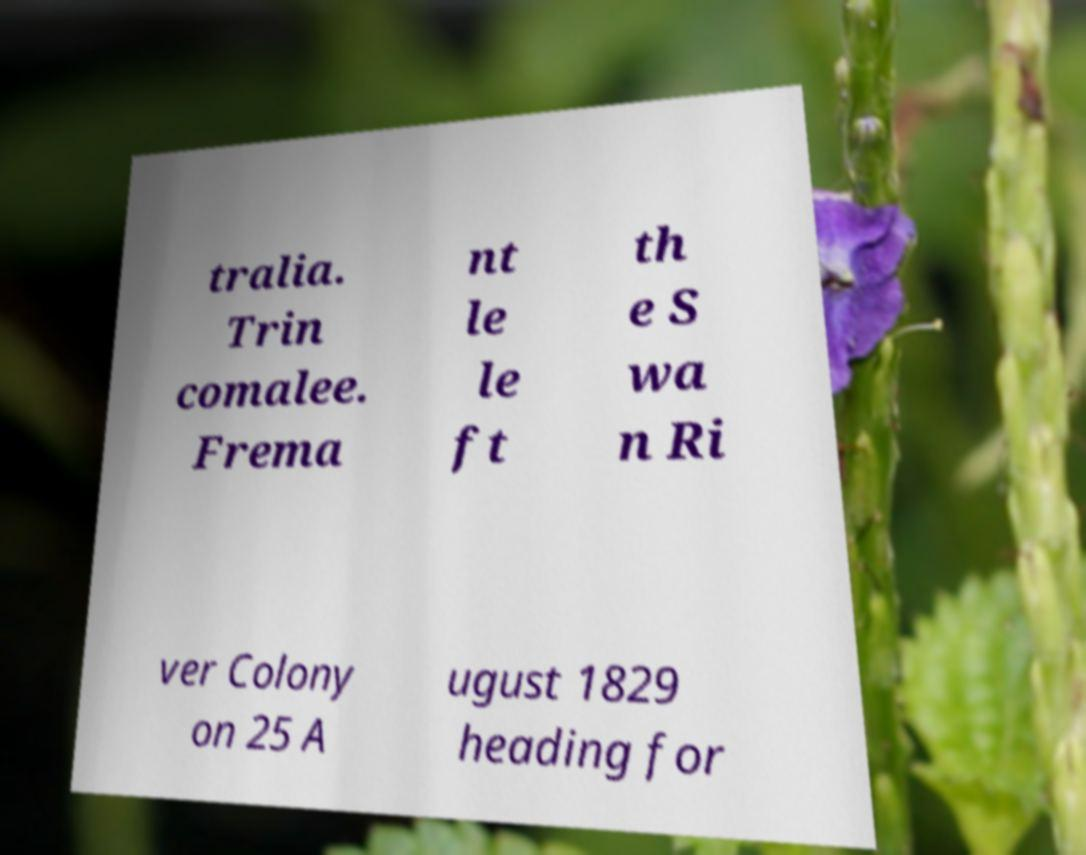I need the written content from this picture converted into text. Can you do that? tralia. Trin comalee. Frema nt le le ft th e S wa n Ri ver Colony on 25 A ugust 1829 heading for 